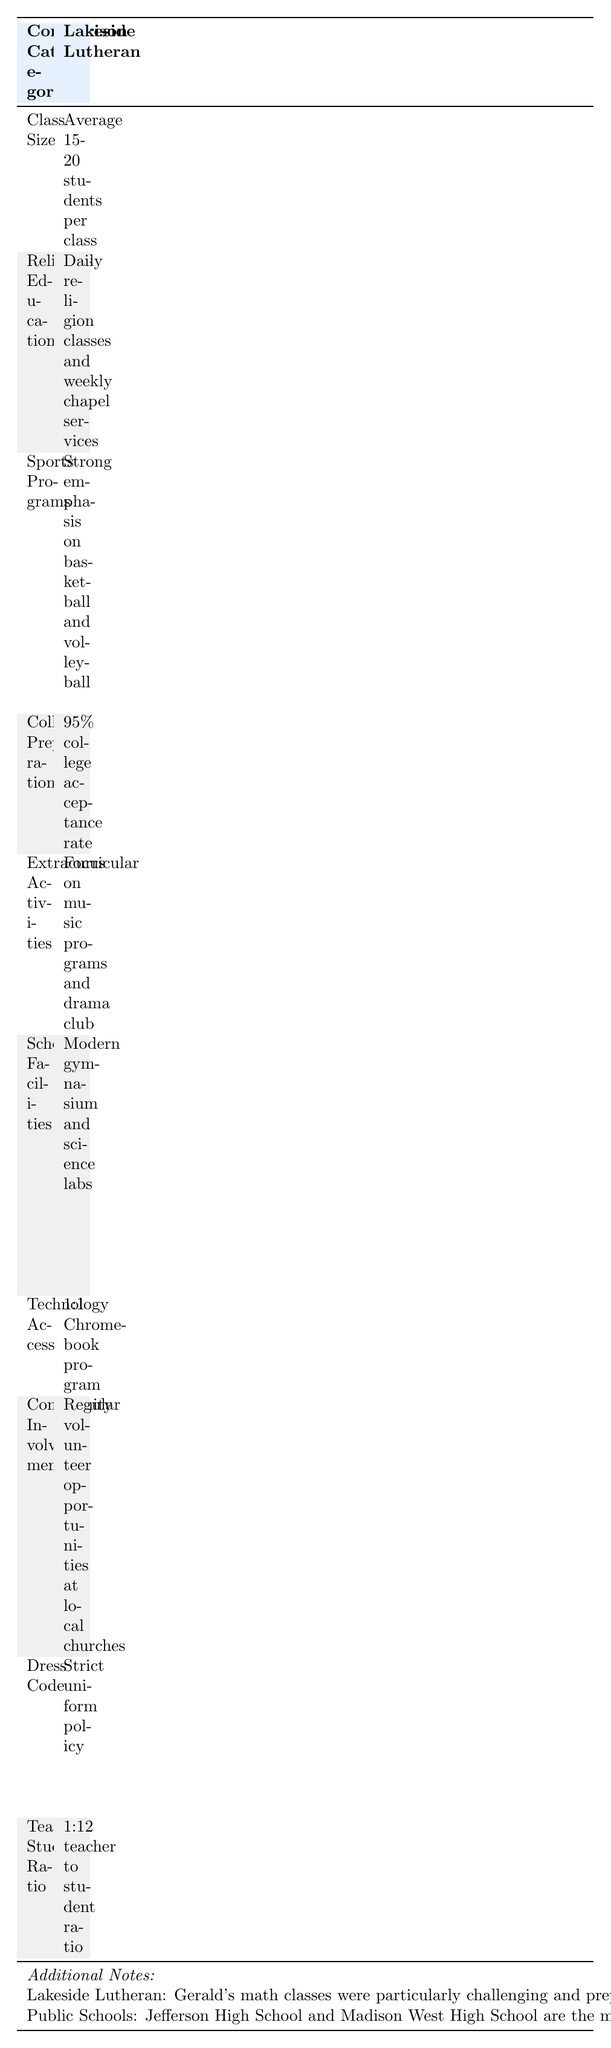What is the average class size at Lakeside Lutheran? The table states that the average class size at Lakeside Lutheran is "Average 15-20 students per class". Therefore, it can be directly referenced from the table.
Answer: Average 15-20 students per class Do Lakeside Lutheran students have daily religious education? According to the table, Lakeside Lutheran has "Daily religion classes and weekly chapel services". So, it confirms that they do indeed have daily religious education.
Answer: Yes What is the teacher-student ratio at public schools? The table indicates that the teacher-student ratio at public schools is "1:18 teacher to student ratio". This information is explicitly provided in the table.
Answer: 1:18 teacher to student ratio What is the difference in college acceptance rates between Lakeside Lutheran and public schools? Lakeside Lutheran has a college acceptance rate of "95%" while public schools have "85%". The difference is calculated as 95% - 85% = 10%.
Answer: 10% Is there a strict dress code at public schools? The table shows that public schools have a "Casual dress code with some restrictions". This implies that while there are some guidelines, it is not strictly enforced.
Answer: No Which school has a stronger emphasis on sports programs? The table states that Lakeside Lutheran has a "Strong emphasis on basketball and volleyball", while public schools have "Diverse sports offerings including football and soccer". The term "strong emphasis" indicates a higher focus compared to the diverse offerings.
Answer: Lakeside Lutheran How many total categories are compared in the table? By counting the number of comparison categories listed, there are 10 different categories presented in the table.
Answer: 10 What does Lakeside Lutheran provide in terms of technology access? According to the table, Lakeside Lutheran offers a "1:1 Chromebook program", meaning that every student has access to their own Chromebook device for technology use in education.
Answer: 1:1 Chromebook program Which school has a focus on community involvement and what does it entail? Lakeside Lutheran has "Regular volunteer opportunities at local churches", indicating a focus on community involvement. Public schools have "Partnerships with local businesses for internships". Both show different forms of community engagement, but Lakeside Lutheran specifically emphasizes volunteer opportunities.
Answer: Lakeside Lutheran with volunteer opportunities at local churches 